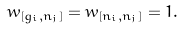Convert formula to latex. <formula><loc_0><loc_0><loc_500><loc_500>w _ { [ g _ { i } , n _ { j } ] } = w _ { [ n _ { i } , n _ { j } ] } = 1 .</formula> 